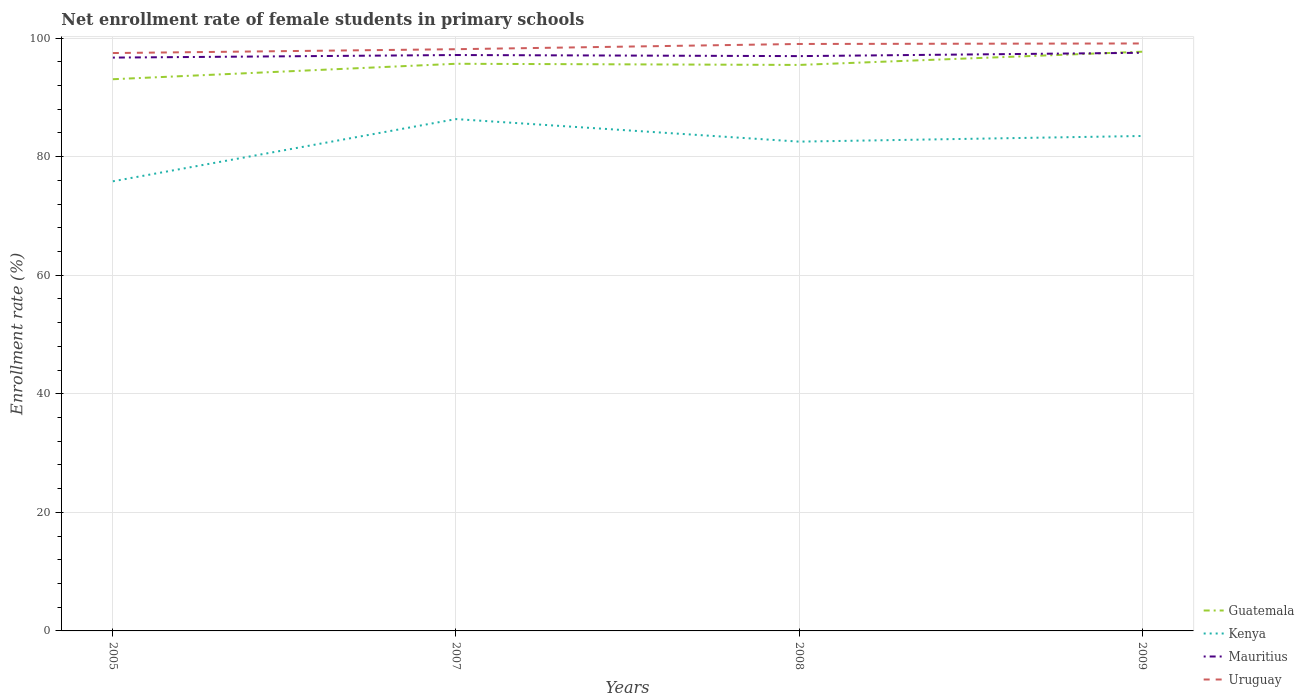Does the line corresponding to Mauritius intersect with the line corresponding to Kenya?
Provide a succinct answer. No. Is the number of lines equal to the number of legend labels?
Provide a short and direct response. Yes. Across all years, what is the maximum net enrollment rate of female students in primary schools in Kenya?
Ensure brevity in your answer.  75.85. What is the total net enrollment rate of female students in primary schools in Mauritius in the graph?
Provide a short and direct response. -0.25. What is the difference between the highest and the second highest net enrollment rate of female students in primary schools in Uruguay?
Provide a short and direct response. 1.62. Is the net enrollment rate of female students in primary schools in Mauritius strictly greater than the net enrollment rate of female students in primary schools in Uruguay over the years?
Your response must be concise. Yes. How many years are there in the graph?
Provide a succinct answer. 4. Are the values on the major ticks of Y-axis written in scientific E-notation?
Ensure brevity in your answer.  No. How many legend labels are there?
Make the answer very short. 4. How are the legend labels stacked?
Offer a very short reply. Vertical. What is the title of the graph?
Your answer should be very brief. Net enrollment rate of female students in primary schools. What is the label or title of the Y-axis?
Offer a terse response. Enrollment rate (%). What is the Enrollment rate (%) of Guatemala in 2005?
Make the answer very short. 93.06. What is the Enrollment rate (%) of Kenya in 2005?
Ensure brevity in your answer.  75.85. What is the Enrollment rate (%) of Mauritius in 2005?
Keep it short and to the point. 96.71. What is the Enrollment rate (%) in Uruguay in 2005?
Your answer should be very brief. 97.48. What is the Enrollment rate (%) of Guatemala in 2007?
Your answer should be very brief. 95.67. What is the Enrollment rate (%) in Kenya in 2007?
Offer a terse response. 86.34. What is the Enrollment rate (%) in Mauritius in 2007?
Offer a terse response. 97.15. What is the Enrollment rate (%) in Uruguay in 2007?
Offer a very short reply. 98.13. What is the Enrollment rate (%) of Guatemala in 2008?
Your response must be concise. 95.47. What is the Enrollment rate (%) of Kenya in 2008?
Ensure brevity in your answer.  82.54. What is the Enrollment rate (%) in Mauritius in 2008?
Your answer should be compact. 96.96. What is the Enrollment rate (%) in Uruguay in 2008?
Offer a terse response. 99.01. What is the Enrollment rate (%) in Guatemala in 2009?
Provide a succinct answer. 97.7. What is the Enrollment rate (%) of Kenya in 2009?
Your answer should be compact. 83.49. What is the Enrollment rate (%) of Mauritius in 2009?
Provide a short and direct response. 97.52. What is the Enrollment rate (%) in Uruguay in 2009?
Give a very brief answer. 99.1. Across all years, what is the maximum Enrollment rate (%) of Guatemala?
Offer a terse response. 97.7. Across all years, what is the maximum Enrollment rate (%) in Kenya?
Your response must be concise. 86.34. Across all years, what is the maximum Enrollment rate (%) of Mauritius?
Provide a short and direct response. 97.52. Across all years, what is the maximum Enrollment rate (%) of Uruguay?
Offer a terse response. 99.1. Across all years, what is the minimum Enrollment rate (%) in Guatemala?
Provide a short and direct response. 93.06. Across all years, what is the minimum Enrollment rate (%) in Kenya?
Provide a succinct answer. 75.85. Across all years, what is the minimum Enrollment rate (%) of Mauritius?
Make the answer very short. 96.71. Across all years, what is the minimum Enrollment rate (%) of Uruguay?
Your response must be concise. 97.48. What is the total Enrollment rate (%) of Guatemala in the graph?
Provide a succinct answer. 381.91. What is the total Enrollment rate (%) of Kenya in the graph?
Provide a short and direct response. 328.21. What is the total Enrollment rate (%) in Mauritius in the graph?
Provide a short and direct response. 388.34. What is the total Enrollment rate (%) of Uruguay in the graph?
Offer a very short reply. 393.71. What is the difference between the Enrollment rate (%) in Guatemala in 2005 and that in 2007?
Offer a very short reply. -2.61. What is the difference between the Enrollment rate (%) of Kenya in 2005 and that in 2007?
Make the answer very short. -10.49. What is the difference between the Enrollment rate (%) of Mauritius in 2005 and that in 2007?
Offer a very short reply. -0.43. What is the difference between the Enrollment rate (%) in Uruguay in 2005 and that in 2007?
Give a very brief answer. -0.65. What is the difference between the Enrollment rate (%) in Guatemala in 2005 and that in 2008?
Your response must be concise. -2.41. What is the difference between the Enrollment rate (%) in Kenya in 2005 and that in 2008?
Offer a terse response. -6.69. What is the difference between the Enrollment rate (%) of Uruguay in 2005 and that in 2008?
Ensure brevity in your answer.  -1.53. What is the difference between the Enrollment rate (%) in Guatemala in 2005 and that in 2009?
Provide a short and direct response. -4.64. What is the difference between the Enrollment rate (%) in Kenya in 2005 and that in 2009?
Give a very brief answer. -7.64. What is the difference between the Enrollment rate (%) of Mauritius in 2005 and that in 2009?
Make the answer very short. -0.81. What is the difference between the Enrollment rate (%) in Uruguay in 2005 and that in 2009?
Your answer should be very brief. -1.62. What is the difference between the Enrollment rate (%) of Guatemala in 2007 and that in 2008?
Provide a succinct answer. 0.2. What is the difference between the Enrollment rate (%) in Kenya in 2007 and that in 2008?
Provide a succinct answer. 3.8. What is the difference between the Enrollment rate (%) of Mauritius in 2007 and that in 2008?
Ensure brevity in your answer.  0.18. What is the difference between the Enrollment rate (%) in Uruguay in 2007 and that in 2008?
Your answer should be compact. -0.88. What is the difference between the Enrollment rate (%) of Guatemala in 2007 and that in 2009?
Provide a succinct answer. -2.03. What is the difference between the Enrollment rate (%) of Kenya in 2007 and that in 2009?
Your answer should be very brief. 2.85. What is the difference between the Enrollment rate (%) in Mauritius in 2007 and that in 2009?
Make the answer very short. -0.38. What is the difference between the Enrollment rate (%) of Uruguay in 2007 and that in 2009?
Provide a short and direct response. -0.97. What is the difference between the Enrollment rate (%) in Guatemala in 2008 and that in 2009?
Your answer should be very brief. -2.23. What is the difference between the Enrollment rate (%) of Kenya in 2008 and that in 2009?
Make the answer very short. -0.95. What is the difference between the Enrollment rate (%) in Mauritius in 2008 and that in 2009?
Provide a succinct answer. -0.56. What is the difference between the Enrollment rate (%) in Uruguay in 2008 and that in 2009?
Your answer should be very brief. -0.08. What is the difference between the Enrollment rate (%) of Guatemala in 2005 and the Enrollment rate (%) of Kenya in 2007?
Your answer should be very brief. 6.72. What is the difference between the Enrollment rate (%) in Guatemala in 2005 and the Enrollment rate (%) in Mauritius in 2007?
Offer a terse response. -4.08. What is the difference between the Enrollment rate (%) in Guatemala in 2005 and the Enrollment rate (%) in Uruguay in 2007?
Give a very brief answer. -5.06. What is the difference between the Enrollment rate (%) of Kenya in 2005 and the Enrollment rate (%) of Mauritius in 2007?
Your answer should be very brief. -21.3. What is the difference between the Enrollment rate (%) in Kenya in 2005 and the Enrollment rate (%) in Uruguay in 2007?
Make the answer very short. -22.28. What is the difference between the Enrollment rate (%) in Mauritius in 2005 and the Enrollment rate (%) in Uruguay in 2007?
Your response must be concise. -1.42. What is the difference between the Enrollment rate (%) in Guatemala in 2005 and the Enrollment rate (%) in Kenya in 2008?
Your response must be concise. 10.53. What is the difference between the Enrollment rate (%) of Guatemala in 2005 and the Enrollment rate (%) of Mauritius in 2008?
Your response must be concise. -3.9. What is the difference between the Enrollment rate (%) in Guatemala in 2005 and the Enrollment rate (%) in Uruguay in 2008?
Give a very brief answer. -5.95. What is the difference between the Enrollment rate (%) in Kenya in 2005 and the Enrollment rate (%) in Mauritius in 2008?
Your answer should be compact. -21.12. What is the difference between the Enrollment rate (%) in Kenya in 2005 and the Enrollment rate (%) in Uruguay in 2008?
Make the answer very short. -23.16. What is the difference between the Enrollment rate (%) in Mauritius in 2005 and the Enrollment rate (%) in Uruguay in 2008?
Give a very brief answer. -2.3. What is the difference between the Enrollment rate (%) of Guatemala in 2005 and the Enrollment rate (%) of Kenya in 2009?
Keep it short and to the point. 9.57. What is the difference between the Enrollment rate (%) in Guatemala in 2005 and the Enrollment rate (%) in Mauritius in 2009?
Your answer should be very brief. -4.46. What is the difference between the Enrollment rate (%) in Guatemala in 2005 and the Enrollment rate (%) in Uruguay in 2009?
Provide a succinct answer. -6.03. What is the difference between the Enrollment rate (%) in Kenya in 2005 and the Enrollment rate (%) in Mauritius in 2009?
Your answer should be compact. -21.68. What is the difference between the Enrollment rate (%) of Kenya in 2005 and the Enrollment rate (%) of Uruguay in 2009?
Your response must be concise. -23.25. What is the difference between the Enrollment rate (%) of Mauritius in 2005 and the Enrollment rate (%) of Uruguay in 2009?
Provide a short and direct response. -2.38. What is the difference between the Enrollment rate (%) of Guatemala in 2007 and the Enrollment rate (%) of Kenya in 2008?
Keep it short and to the point. 13.13. What is the difference between the Enrollment rate (%) in Guatemala in 2007 and the Enrollment rate (%) in Mauritius in 2008?
Ensure brevity in your answer.  -1.29. What is the difference between the Enrollment rate (%) of Guatemala in 2007 and the Enrollment rate (%) of Uruguay in 2008?
Your answer should be compact. -3.34. What is the difference between the Enrollment rate (%) in Kenya in 2007 and the Enrollment rate (%) in Mauritius in 2008?
Provide a short and direct response. -10.62. What is the difference between the Enrollment rate (%) of Kenya in 2007 and the Enrollment rate (%) of Uruguay in 2008?
Ensure brevity in your answer.  -12.67. What is the difference between the Enrollment rate (%) of Mauritius in 2007 and the Enrollment rate (%) of Uruguay in 2008?
Your answer should be compact. -1.86. What is the difference between the Enrollment rate (%) of Guatemala in 2007 and the Enrollment rate (%) of Kenya in 2009?
Offer a terse response. 12.18. What is the difference between the Enrollment rate (%) of Guatemala in 2007 and the Enrollment rate (%) of Mauritius in 2009?
Your response must be concise. -1.85. What is the difference between the Enrollment rate (%) in Guatemala in 2007 and the Enrollment rate (%) in Uruguay in 2009?
Provide a succinct answer. -3.43. What is the difference between the Enrollment rate (%) of Kenya in 2007 and the Enrollment rate (%) of Mauritius in 2009?
Your answer should be compact. -11.18. What is the difference between the Enrollment rate (%) in Kenya in 2007 and the Enrollment rate (%) in Uruguay in 2009?
Offer a terse response. -12.76. What is the difference between the Enrollment rate (%) of Mauritius in 2007 and the Enrollment rate (%) of Uruguay in 2009?
Keep it short and to the point. -1.95. What is the difference between the Enrollment rate (%) of Guatemala in 2008 and the Enrollment rate (%) of Kenya in 2009?
Provide a succinct answer. 11.98. What is the difference between the Enrollment rate (%) of Guatemala in 2008 and the Enrollment rate (%) of Mauritius in 2009?
Your answer should be very brief. -2.05. What is the difference between the Enrollment rate (%) in Guatemala in 2008 and the Enrollment rate (%) in Uruguay in 2009?
Provide a succinct answer. -3.62. What is the difference between the Enrollment rate (%) of Kenya in 2008 and the Enrollment rate (%) of Mauritius in 2009?
Provide a succinct answer. -14.98. What is the difference between the Enrollment rate (%) of Kenya in 2008 and the Enrollment rate (%) of Uruguay in 2009?
Your answer should be very brief. -16.56. What is the difference between the Enrollment rate (%) of Mauritius in 2008 and the Enrollment rate (%) of Uruguay in 2009?
Offer a terse response. -2.13. What is the average Enrollment rate (%) in Guatemala per year?
Offer a very short reply. 95.48. What is the average Enrollment rate (%) in Kenya per year?
Make the answer very short. 82.05. What is the average Enrollment rate (%) of Mauritius per year?
Make the answer very short. 97.09. What is the average Enrollment rate (%) in Uruguay per year?
Offer a very short reply. 98.43. In the year 2005, what is the difference between the Enrollment rate (%) of Guatemala and Enrollment rate (%) of Kenya?
Make the answer very short. 17.22. In the year 2005, what is the difference between the Enrollment rate (%) in Guatemala and Enrollment rate (%) in Mauritius?
Offer a very short reply. -3.65. In the year 2005, what is the difference between the Enrollment rate (%) in Guatemala and Enrollment rate (%) in Uruguay?
Your answer should be compact. -4.41. In the year 2005, what is the difference between the Enrollment rate (%) of Kenya and Enrollment rate (%) of Mauritius?
Make the answer very short. -20.87. In the year 2005, what is the difference between the Enrollment rate (%) of Kenya and Enrollment rate (%) of Uruguay?
Offer a very short reply. -21.63. In the year 2005, what is the difference between the Enrollment rate (%) of Mauritius and Enrollment rate (%) of Uruguay?
Ensure brevity in your answer.  -0.77. In the year 2007, what is the difference between the Enrollment rate (%) in Guatemala and Enrollment rate (%) in Kenya?
Keep it short and to the point. 9.33. In the year 2007, what is the difference between the Enrollment rate (%) of Guatemala and Enrollment rate (%) of Mauritius?
Offer a terse response. -1.48. In the year 2007, what is the difference between the Enrollment rate (%) in Guatemala and Enrollment rate (%) in Uruguay?
Ensure brevity in your answer.  -2.46. In the year 2007, what is the difference between the Enrollment rate (%) in Kenya and Enrollment rate (%) in Mauritius?
Keep it short and to the point. -10.81. In the year 2007, what is the difference between the Enrollment rate (%) in Kenya and Enrollment rate (%) in Uruguay?
Give a very brief answer. -11.79. In the year 2007, what is the difference between the Enrollment rate (%) of Mauritius and Enrollment rate (%) of Uruguay?
Your answer should be very brief. -0.98. In the year 2008, what is the difference between the Enrollment rate (%) of Guatemala and Enrollment rate (%) of Kenya?
Provide a short and direct response. 12.94. In the year 2008, what is the difference between the Enrollment rate (%) in Guatemala and Enrollment rate (%) in Mauritius?
Offer a terse response. -1.49. In the year 2008, what is the difference between the Enrollment rate (%) of Guatemala and Enrollment rate (%) of Uruguay?
Your answer should be compact. -3.54. In the year 2008, what is the difference between the Enrollment rate (%) of Kenya and Enrollment rate (%) of Mauritius?
Provide a succinct answer. -14.42. In the year 2008, what is the difference between the Enrollment rate (%) of Kenya and Enrollment rate (%) of Uruguay?
Ensure brevity in your answer.  -16.47. In the year 2008, what is the difference between the Enrollment rate (%) in Mauritius and Enrollment rate (%) in Uruguay?
Give a very brief answer. -2.05. In the year 2009, what is the difference between the Enrollment rate (%) in Guatemala and Enrollment rate (%) in Kenya?
Your response must be concise. 14.21. In the year 2009, what is the difference between the Enrollment rate (%) of Guatemala and Enrollment rate (%) of Mauritius?
Keep it short and to the point. 0.18. In the year 2009, what is the difference between the Enrollment rate (%) of Guatemala and Enrollment rate (%) of Uruguay?
Provide a succinct answer. -1.39. In the year 2009, what is the difference between the Enrollment rate (%) of Kenya and Enrollment rate (%) of Mauritius?
Offer a very short reply. -14.03. In the year 2009, what is the difference between the Enrollment rate (%) of Kenya and Enrollment rate (%) of Uruguay?
Provide a succinct answer. -15.61. In the year 2009, what is the difference between the Enrollment rate (%) in Mauritius and Enrollment rate (%) in Uruguay?
Provide a succinct answer. -1.57. What is the ratio of the Enrollment rate (%) in Guatemala in 2005 to that in 2007?
Provide a succinct answer. 0.97. What is the ratio of the Enrollment rate (%) in Kenya in 2005 to that in 2007?
Your response must be concise. 0.88. What is the ratio of the Enrollment rate (%) of Mauritius in 2005 to that in 2007?
Your answer should be compact. 1. What is the ratio of the Enrollment rate (%) of Guatemala in 2005 to that in 2008?
Offer a very short reply. 0.97. What is the ratio of the Enrollment rate (%) of Kenya in 2005 to that in 2008?
Make the answer very short. 0.92. What is the ratio of the Enrollment rate (%) of Mauritius in 2005 to that in 2008?
Offer a terse response. 1. What is the ratio of the Enrollment rate (%) of Uruguay in 2005 to that in 2008?
Your response must be concise. 0.98. What is the ratio of the Enrollment rate (%) of Guatemala in 2005 to that in 2009?
Make the answer very short. 0.95. What is the ratio of the Enrollment rate (%) of Kenya in 2005 to that in 2009?
Ensure brevity in your answer.  0.91. What is the ratio of the Enrollment rate (%) in Uruguay in 2005 to that in 2009?
Provide a short and direct response. 0.98. What is the ratio of the Enrollment rate (%) in Guatemala in 2007 to that in 2008?
Provide a short and direct response. 1. What is the ratio of the Enrollment rate (%) in Kenya in 2007 to that in 2008?
Make the answer very short. 1.05. What is the ratio of the Enrollment rate (%) in Mauritius in 2007 to that in 2008?
Provide a short and direct response. 1. What is the ratio of the Enrollment rate (%) in Uruguay in 2007 to that in 2008?
Offer a terse response. 0.99. What is the ratio of the Enrollment rate (%) of Guatemala in 2007 to that in 2009?
Keep it short and to the point. 0.98. What is the ratio of the Enrollment rate (%) in Kenya in 2007 to that in 2009?
Provide a succinct answer. 1.03. What is the ratio of the Enrollment rate (%) in Uruguay in 2007 to that in 2009?
Make the answer very short. 0.99. What is the ratio of the Enrollment rate (%) in Guatemala in 2008 to that in 2009?
Make the answer very short. 0.98. What is the ratio of the Enrollment rate (%) in Kenya in 2008 to that in 2009?
Make the answer very short. 0.99. What is the difference between the highest and the second highest Enrollment rate (%) in Guatemala?
Provide a succinct answer. 2.03. What is the difference between the highest and the second highest Enrollment rate (%) in Kenya?
Your answer should be very brief. 2.85. What is the difference between the highest and the second highest Enrollment rate (%) in Mauritius?
Keep it short and to the point. 0.38. What is the difference between the highest and the second highest Enrollment rate (%) of Uruguay?
Keep it short and to the point. 0.08. What is the difference between the highest and the lowest Enrollment rate (%) of Guatemala?
Offer a terse response. 4.64. What is the difference between the highest and the lowest Enrollment rate (%) in Kenya?
Make the answer very short. 10.49. What is the difference between the highest and the lowest Enrollment rate (%) in Mauritius?
Ensure brevity in your answer.  0.81. What is the difference between the highest and the lowest Enrollment rate (%) in Uruguay?
Your response must be concise. 1.62. 